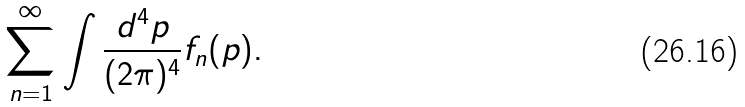Convert formula to latex. <formula><loc_0><loc_0><loc_500><loc_500>\sum _ { n = 1 } ^ { \infty } \int \frac { d ^ { 4 } p } { ( 2 \pi ) ^ { 4 } } f _ { n } ( p ) .</formula> 